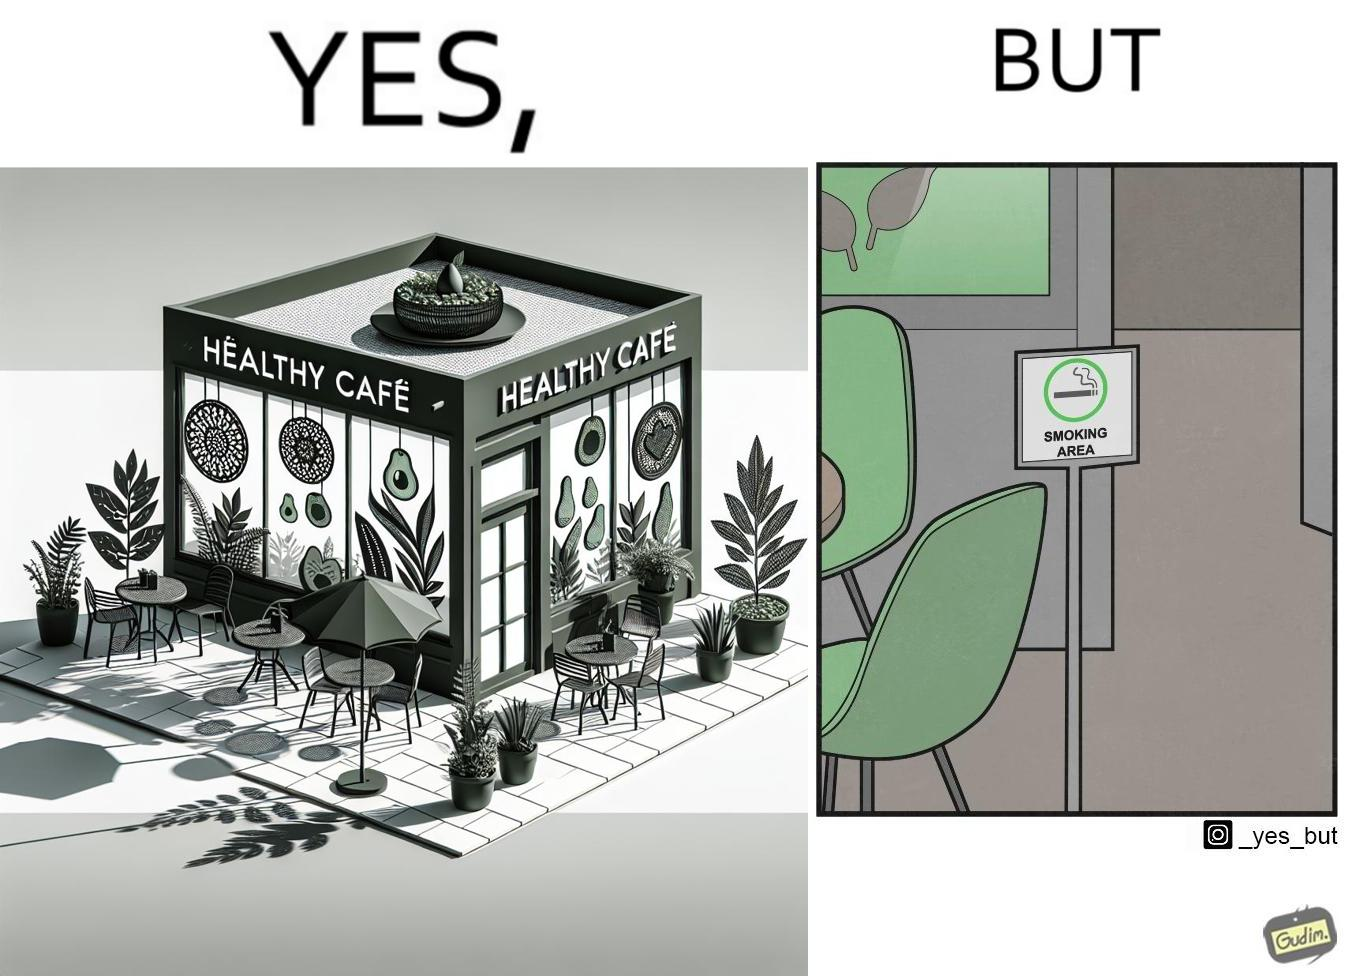Provide a description of this image. This image is funny because an eatery that calls itself the "healthy" cafe also has a smoking area, which is not very "healthy". If it really was a healthy cafe, it would not have a smoking area as smoking is injurious to health. Satire on the behavior of humans - both those that operate this cafe who made the decision of allowing smoking and creating a designated smoking area, and those that visit this healthy cafe to become "healthy", but then also indulge in very unhealthy habits simultaneously. 